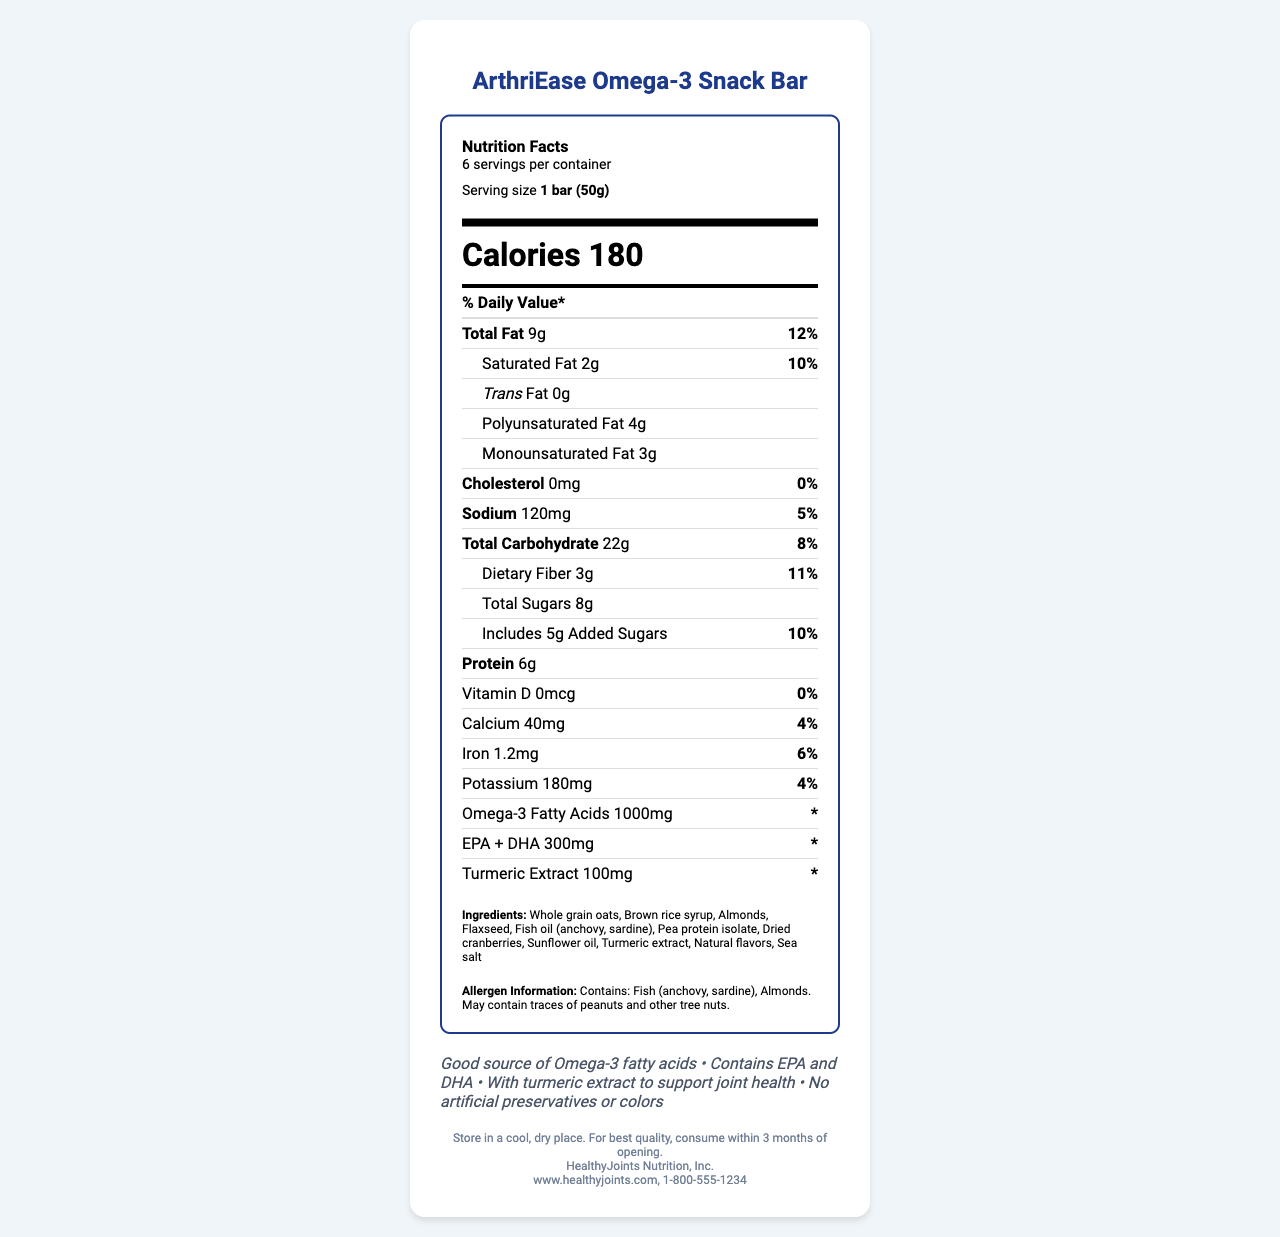what is the serving size of the ArthriEase Omega-3 Snack Bar? The serving size is stated as "1 bar (50g)" in the serving information section of the nutrition label.
Answer: 1 bar (50g) how many calories are in one serving of the snack bar? The number of calories per serving is listed as "Calories 180" in the document.
Answer: 180 how much polyunsaturated fat does one bar contain? The amount of polyunsaturated fat is listed under the fat composition section.
Answer: 4g what is the daily value percentage of saturated fat? The daily value for saturated fat is given as "10%" in the information displayed next to the amount of saturated fat.
Answer: 10% which ingredient is used for omega-3 fortification in the snack bar? The ingredients list includes "Fish oil (anchovy, sardine)" which provides omega-3 fatty acids.
Answer: Fish oil (anchovy, sardine) how much sodium is in one serving of the snack bar? The sodium content per serving is stated as "120mg".
Answer: 120mg what are the allergens present in the snack bar? A. Fish and almonds B. Peanuts and soy C. Gluten and dairy The allergen information specifies "Contains: Fish (anchovy, sardine), Almonds."
Answer: A. Fish and almonds what is the total carbohydrate content per serving? A. 18g B. 22g C. 25g The total carbohydrate content is listed as "22g".
Answer: B. 22g does the snack bar contain any trans fat? The document specifies "Trans Fat 0g", indicating there is no trans fat.
Answer: No is the snack bar a good source of Omega-3 fatty acids? One of the health claims explicitly states that the snack bar is a "Good source of Omega-3 fatty acids".
Answer: Yes summarize the main idea of this document. The document details the nutritional facts for a specialized snack bar intended to reduce inflammation in arthritis patients, emphasizing its omega-3 content and anti-inflammatory properties.
Answer: The document provides the nutritional information for the ArthriEase Omega-3 Snack Bar, highlighting its benefits for individuals with arthritis, such as being a good source of omega-3 fatty acids and containing ingredients like turmeric extract for joint health. It also includes statistics on calories, fats, carbohydrates, and protein, as well as additional health claims and allergen information. what type of fiber is included in the snack bar? The document lists "Dietary Fiber" as an ingredient but does not specify the type.
Answer: Cannot be determined how should the snack bar be stored after opening? The storage instructions clearly state to store the product in a cool, dry place and consume within 3 months of opening.
Answer: Store in a cool, dry place. For best quality, consume within 3 months of opening. how many servings are there per container of the snack bar? The document states that there are "6 servings per container".
Answer: 6 